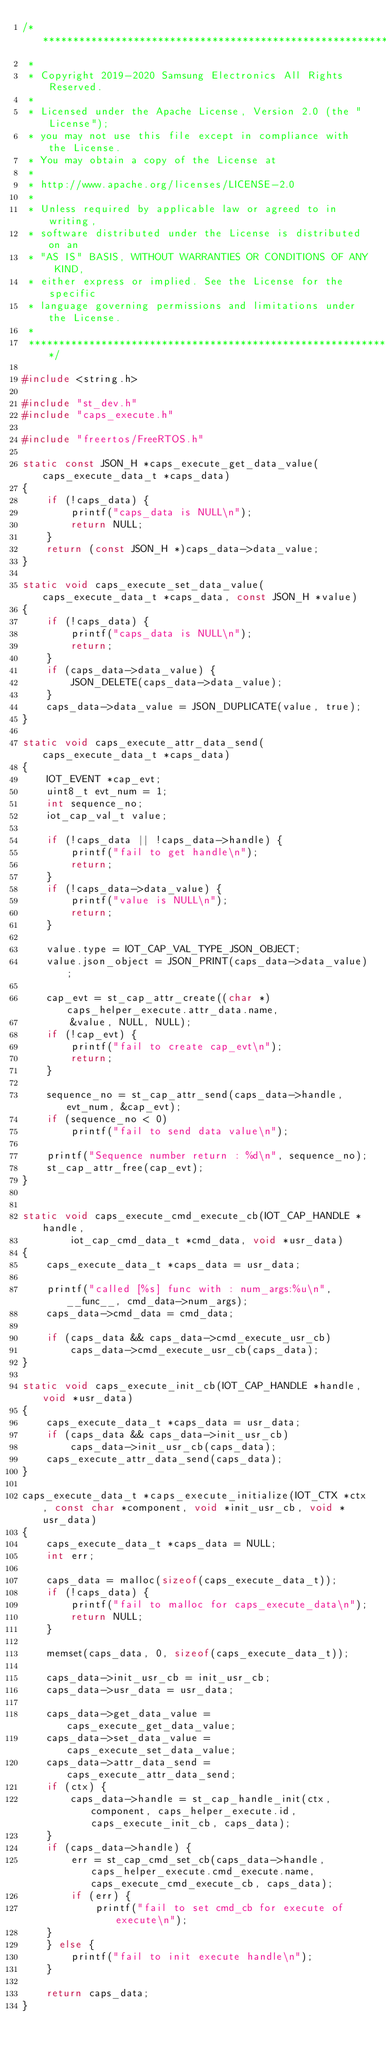Convert code to text. <code><loc_0><loc_0><loc_500><loc_500><_C_>/* ***************************************************************************
 *
 * Copyright 2019-2020 Samsung Electronics All Rights Reserved.
 *
 * Licensed under the Apache License, Version 2.0 (the "License");
 * you may not use this file except in compliance with the License.
 * You may obtain a copy of the License at
 *
 * http://www.apache.org/licenses/LICENSE-2.0
 *
 * Unless required by applicable law or agreed to in writing,
 * software distributed under the License is distributed on an
 * "AS IS" BASIS, WITHOUT WARRANTIES OR CONDITIONS OF ANY KIND,
 * either express or implied. See the License for the specific
 * language governing permissions and limitations under the License.
 *
 ****************************************************************************/

#include <string.h>

#include "st_dev.h"
#include "caps_execute.h"

#include "freertos/FreeRTOS.h"

static const JSON_H *caps_execute_get_data_value(caps_execute_data_t *caps_data)
{
    if (!caps_data) {
        printf("caps_data is NULL\n");
        return NULL;
    }
    return (const JSON_H *)caps_data->data_value;
}

static void caps_execute_set_data_value(caps_execute_data_t *caps_data, const JSON_H *value)
{
    if (!caps_data) {
        printf("caps_data is NULL\n");
        return;
    }
    if (caps_data->data_value) {
        JSON_DELETE(caps_data->data_value);
    }
    caps_data->data_value = JSON_DUPLICATE(value, true);
}

static void caps_execute_attr_data_send(caps_execute_data_t *caps_data)
{
    IOT_EVENT *cap_evt;
    uint8_t evt_num = 1;
    int sequence_no;
    iot_cap_val_t value;

    if (!caps_data || !caps_data->handle) {
        printf("fail to get handle\n");
        return;
    }
    if (!caps_data->data_value) {
        printf("value is NULL\n");
        return;
    }

    value.type = IOT_CAP_VAL_TYPE_JSON_OBJECT;
    value.json_object = JSON_PRINT(caps_data->data_value);

    cap_evt = st_cap_attr_create((char *)caps_helper_execute.attr_data.name,
        &value, NULL, NULL);
    if (!cap_evt) {
        printf("fail to create cap_evt\n");
        return;
    }

    sequence_no = st_cap_attr_send(caps_data->handle, evt_num, &cap_evt);
    if (sequence_no < 0)
        printf("fail to send data value\n");

    printf("Sequence number return : %d\n", sequence_no);
    st_cap_attr_free(cap_evt);
}


static void caps_execute_cmd_execute_cb(IOT_CAP_HANDLE *handle,
        iot_cap_cmd_data_t *cmd_data, void *usr_data)
{
    caps_execute_data_t *caps_data = usr_data;

    printf("called [%s] func with : num_args:%u\n", __func__, cmd_data->num_args);
    caps_data->cmd_data = cmd_data;

    if (caps_data && caps_data->cmd_execute_usr_cb)
        caps_data->cmd_execute_usr_cb(caps_data);
}

static void caps_execute_init_cb(IOT_CAP_HANDLE *handle, void *usr_data)
{
    caps_execute_data_t *caps_data = usr_data;
    if (caps_data && caps_data->init_usr_cb)
        caps_data->init_usr_cb(caps_data);
    caps_execute_attr_data_send(caps_data);
}

caps_execute_data_t *caps_execute_initialize(IOT_CTX *ctx, const char *component, void *init_usr_cb, void *usr_data)
{
    caps_execute_data_t *caps_data = NULL;
    int err;

    caps_data = malloc(sizeof(caps_execute_data_t));
    if (!caps_data) {
        printf("fail to malloc for caps_execute_data\n");
        return NULL;
    }

    memset(caps_data, 0, sizeof(caps_execute_data_t));

    caps_data->init_usr_cb = init_usr_cb;
    caps_data->usr_data = usr_data;

    caps_data->get_data_value = caps_execute_get_data_value;
    caps_data->set_data_value = caps_execute_set_data_value;
    caps_data->attr_data_send = caps_execute_attr_data_send;
    if (ctx) {
        caps_data->handle = st_cap_handle_init(ctx, component, caps_helper_execute.id, caps_execute_init_cb, caps_data);
    }
    if (caps_data->handle) {
        err = st_cap_cmd_set_cb(caps_data->handle, caps_helper_execute.cmd_execute.name, caps_execute_cmd_execute_cb, caps_data);
        if (err) {
            printf("fail to set cmd_cb for execute of execute\n");
    }
    } else {
        printf("fail to init execute handle\n");
    }

    return caps_data;
}
</code> 